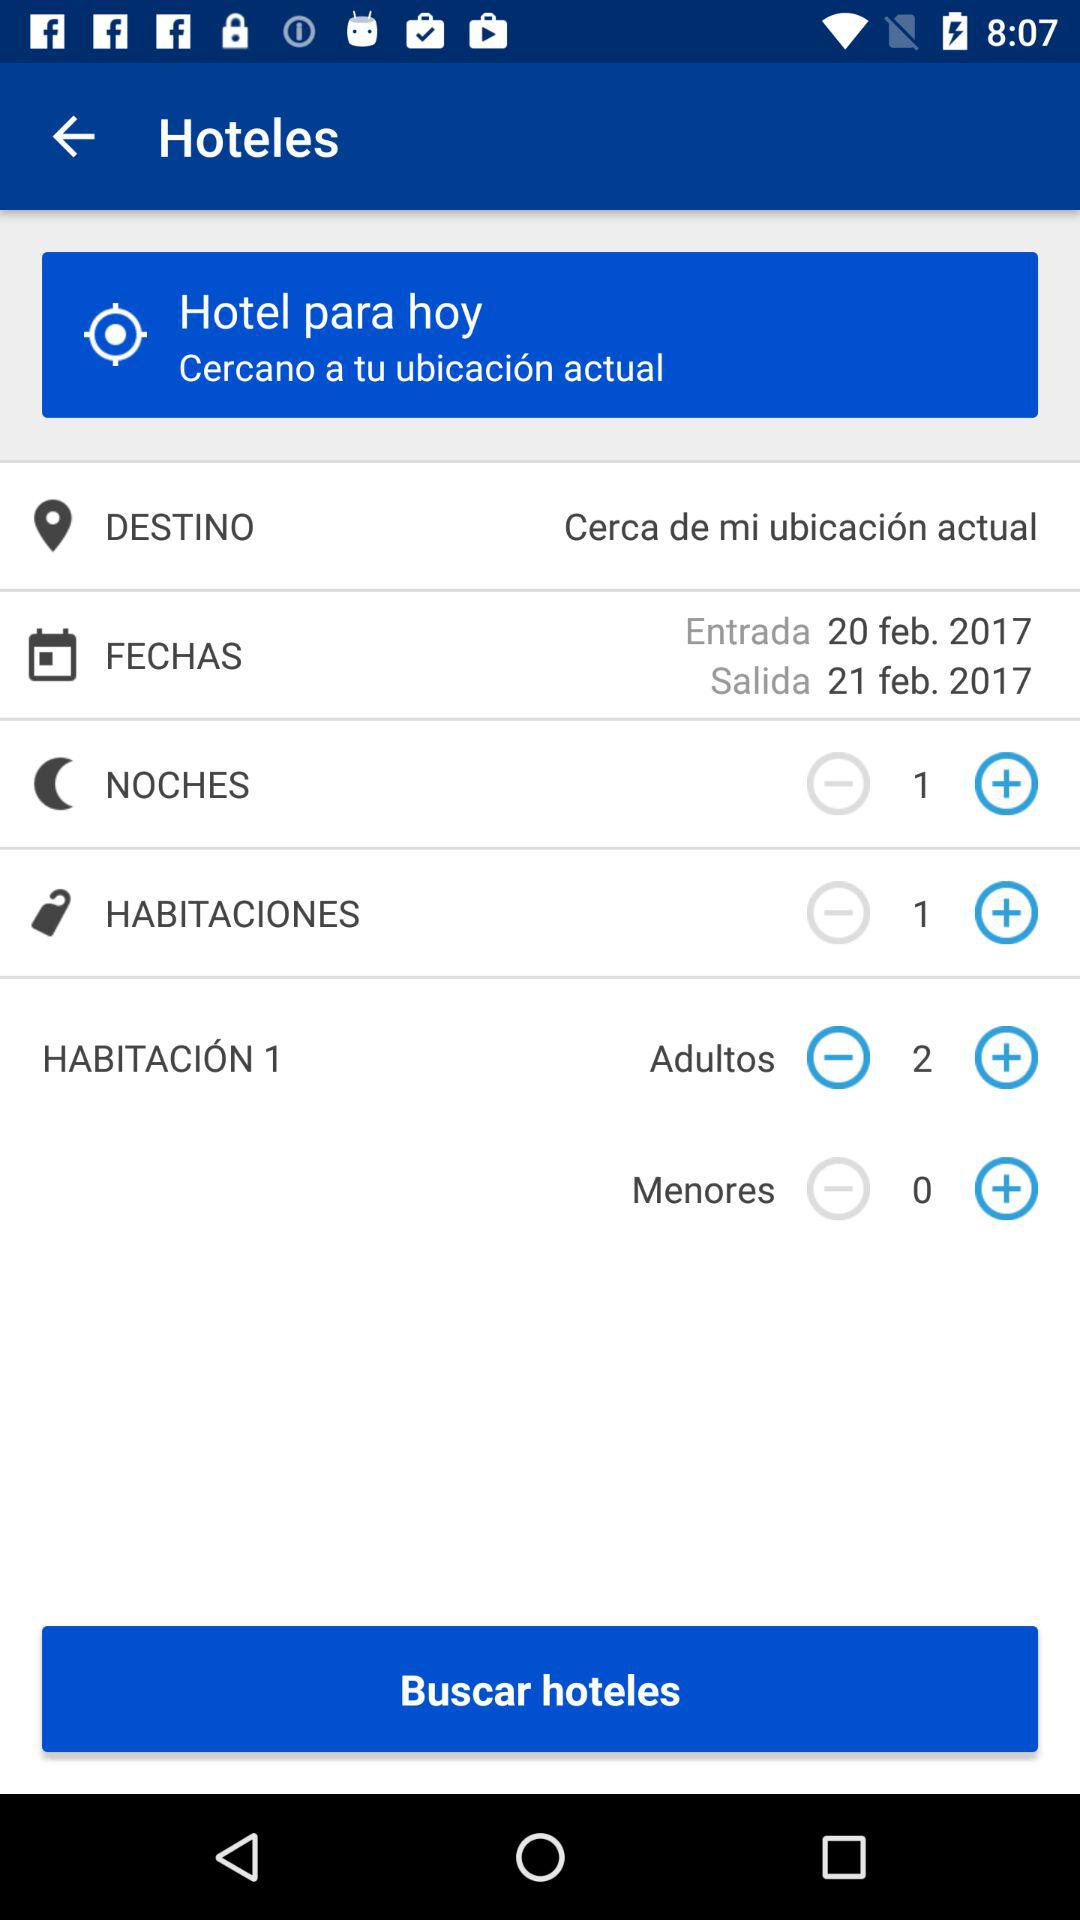How many adults are selected?
Answer the question using a single word or phrase. 2 